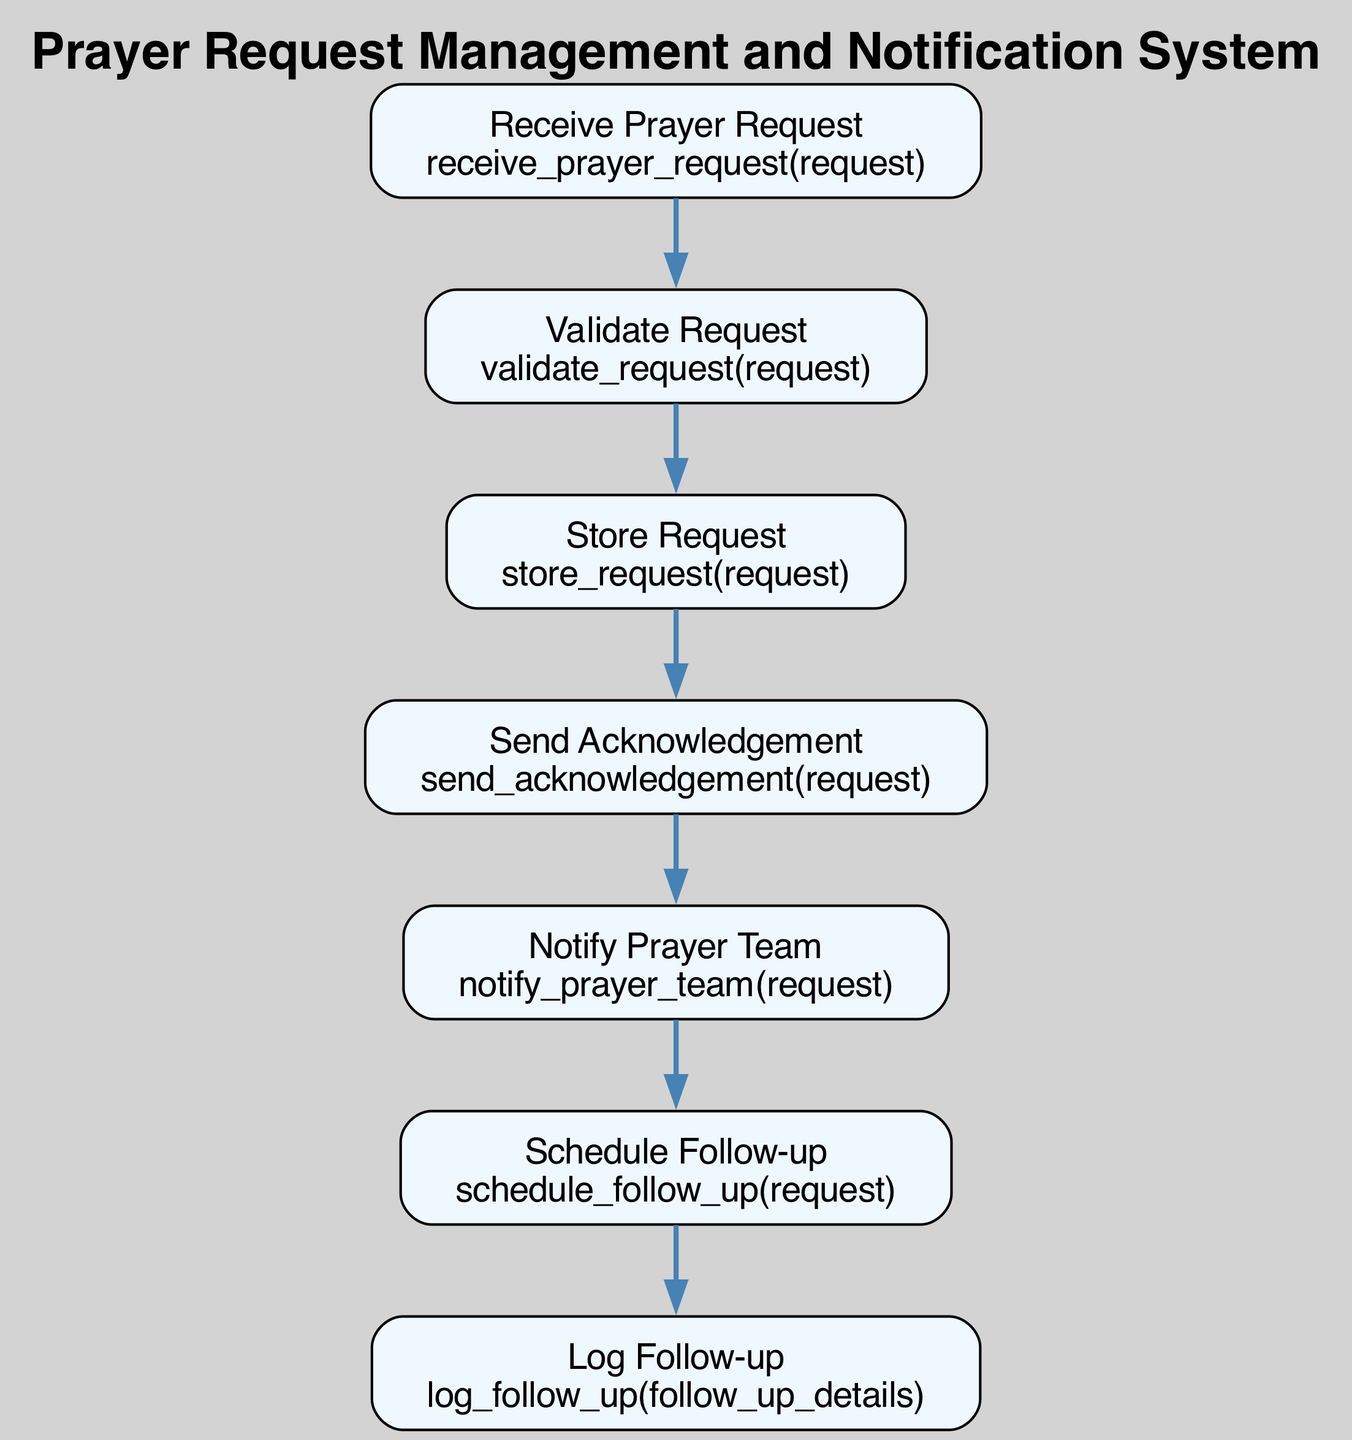What is the first step in the flowchart? The first step in the flowchart is indicated by the top node, which says "Receive Prayer Request". This node signifies the starting point where a prayer request is received.
Answer: Receive Prayer Request How many steps are there in the Prayer Request Management process? To find the total steps, count all nodes in the flowchart. There are seven steps, starting from "Receive Prayer Request" to "Log Follow-up".
Answer: Seven What function is called to send an acknowledgement? The node "Send Acknowledgement" specifies that the function called is "send_acknowledgement(request)", indicating the action of sending a confirmation message.
Answer: send_acknowledgement(request) Which node directly follows the "Validate Request" step? "Store Request" is the step that comes directly after "Validate Request", indicating the sequence in the flow of the process.
Answer: Store Request What is the purpose of the "Log Follow-up" step? The "Log Follow-up" step is to record the outcome of the follow-up action for tracking the support provided to the requester. This purpose is conveyed by the description associated with the node.
Answer: Record the outcome Which function is responsible for notifying the prayer team? The "Notify Prayer Team" node states that the function "notify_prayer_team(request)" is responsible for alerting the prayer team about a new prayer request.
Answer: notify_prayer_team(request) What follows after "Notify Prayer Team"? The flowchart indicates that "Schedule Follow-up" comes after "Notify Prayer Team", showing the subsequent action taken after notifying the team.
Answer: Schedule Follow-up How does the process confirm that a request was received? The process confirms receipt via the "Send Acknowledgement" step, where an acknowledgement message is sent to the requester, thus ensuring they know their request was received.
Answer: Send Acknowledgement What is the last step in this management process? The last step in the flow is "Log Follow-up", which indicates the completion of the prayer request flow by documenting the follow-up details.
Answer: Log Follow-up 